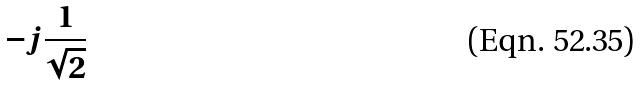<formula> <loc_0><loc_0><loc_500><loc_500>- j \frac { 1 } { \sqrt { 2 } }</formula> 